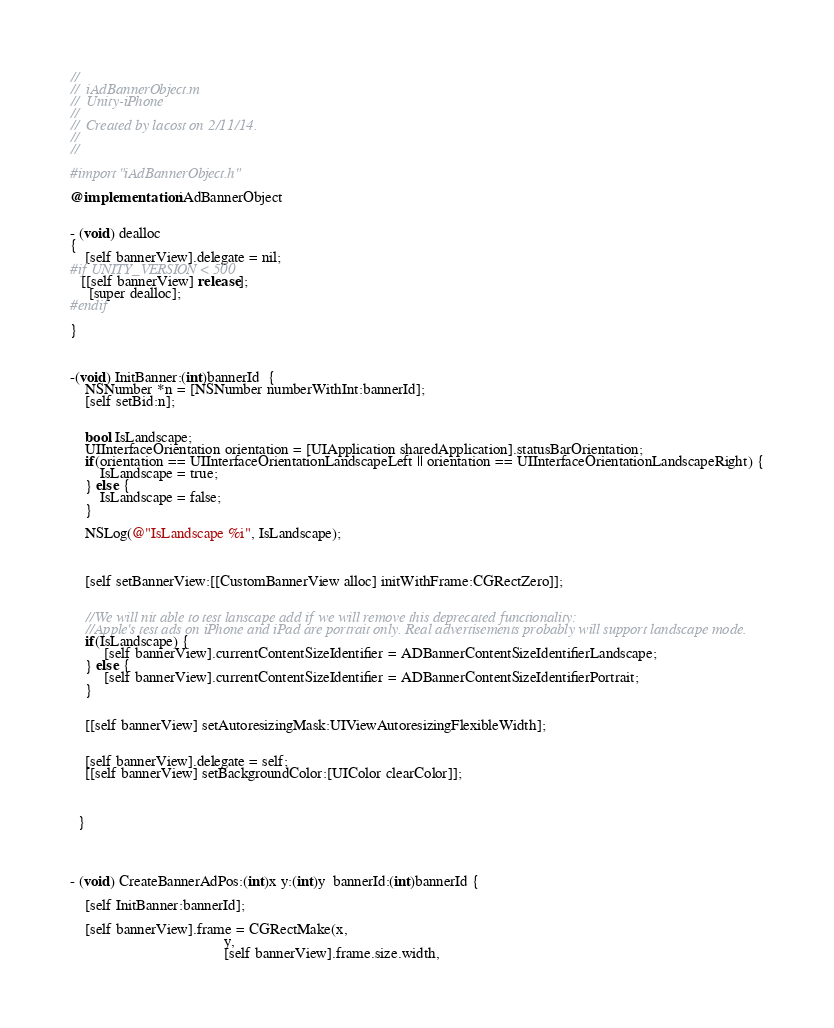Convert code to text. <code><loc_0><loc_0><loc_500><loc_500><_ObjectiveC_>//
//  iAdBannerObject.m
//  Unity-iPhone
//
//  Created by lacost on 2/11/14.
//
//

#import "iAdBannerObject.h"

@implementation iAdBannerObject


- (void) dealloc
{
    [self bannerView].delegate = nil;
#if UNITY_VERSION < 500
   [[self bannerView] release];
     [super dealloc];
#endif
    
}



-(void) InitBanner:(int)bannerId  {
    NSNumber *n = [NSNumber numberWithInt:bannerId];
    [self setBid:n];
    
    
    bool IsLandscape;
    UIInterfaceOrientation orientation = [UIApplication sharedApplication].statusBarOrientation;
    if(orientation == UIInterfaceOrientationLandscapeLeft || orientation == UIInterfaceOrientationLandscapeRight) {
        IsLandscape = true;
    } else {
        IsLandscape = false;
    }
    
    NSLog(@"IsLandscape %i", IsLandscape);
    
    
    
    [self setBannerView:[[CustomBannerView alloc] initWithFrame:CGRectZero]];
    
    
    //We will nit able to test lanscape add if we will remove this deprecated functionality:
    //Apple's test ads on iPhone and iPad are portrait only. Real advertisements probably will support landscape mode.
    if(IsLandscape) {
         [self bannerView].currentContentSizeIdentifier = ADBannerContentSizeIdentifierLandscape;
    } else {
         [self bannerView].currentContentSizeIdentifier = ADBannerContentSizeIdentifierPortrait;
    }
    
    
    [[self bannerView] setAutoresizingMask:UIViewAutoresizingFlexibleWidth];
   
 
    [self bannerView].delegate = self;
    [[self bannerView] setBackgroundColor:[UIColor clearColor]];
   
   
    
  }




- (void) CreateBannerAdPos:(int)x y:(int)y  bannerId:(int)bannerId {
    
    [self InitBanner:bannerId];
    
    [self bannerView].frame = CGRectMake(x,
                                         y,
                                         [self bannerView].frame.size.width,</code> 